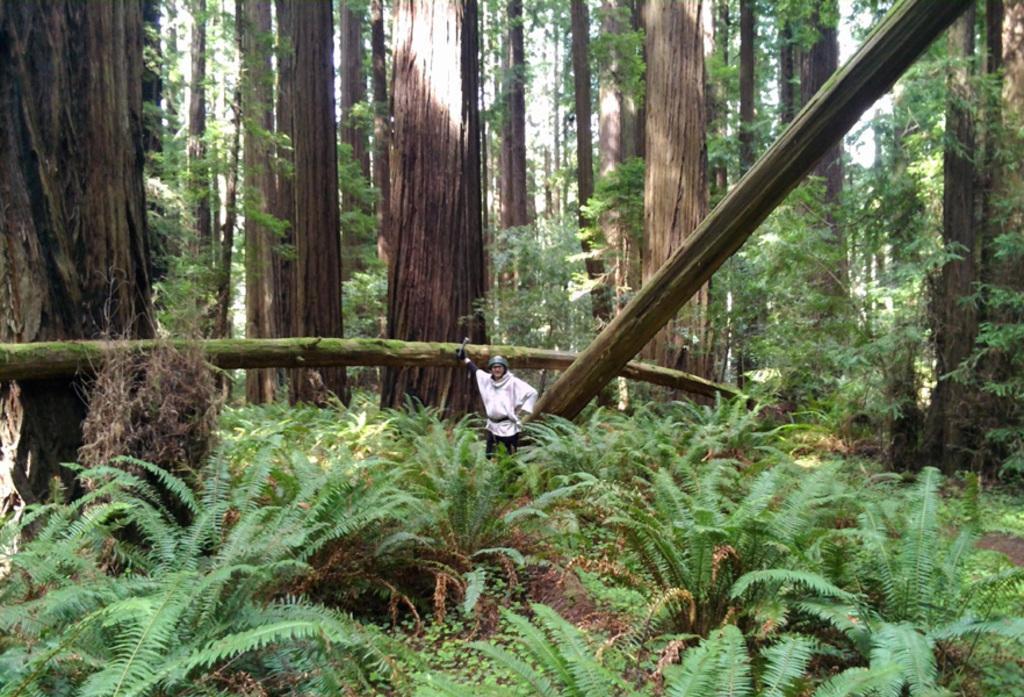Could you give a brief overview of what you see in this image? There is a person standing. We can see plants and trees. 